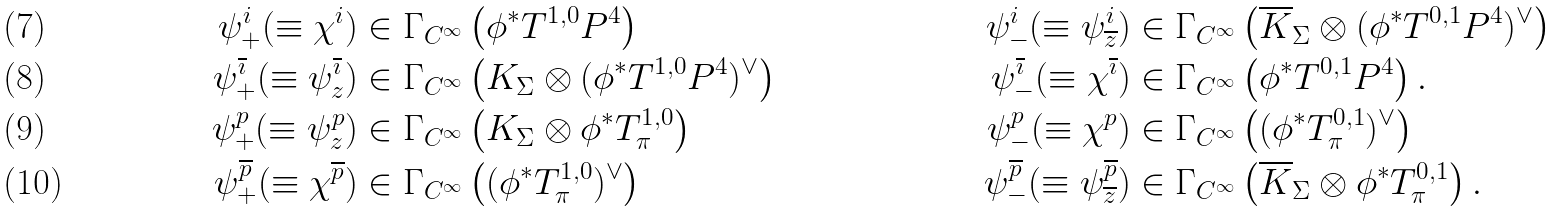<formula> <loc_0><loc_0><loc_500><loc_500>\psi _ { + } ^ { i } ( \equiv \chi ^ { i } ) & \in \Gamma _ { C ^ { \infty } } \left ( \phi ^ { * } T ^ { 1 , 0 } { P } ^ { 4 } \right ) & \psi _ { - } ^ { i } ( \equiv \psi _ { \overline { z } } ^ { i } ) & \in \Gamma _ { C ^ { \infty } } \left ( \overline { K } _ { \Sigma } \otimes ( \phi ^ { * } T ^ { 0 , 1 } { P } ^ { 4 } ) ^ { \vee } \right ) \\ \psi _ { + } ^ { \overline { \imath } } ( \equiv \psi _ { z } ^ { \overline { \imath } } ) & \in \Gamma _ { C ^ { \infty } } \left ( K _ { \Sigma } \otimes ( \phi ^ { * } T ^ { 1 , 0 } { P } ^ { 4 } ) ^ { \vee } \right ) & \psi _ { - } ^ { \overline { \imath } } ( \equiv \chi ^ { \overline { \imath } } ) & \in \Gamma _ { C ^ { \infty } } \left ( \phi ^ { * } T ^ { 0 , 1 } { P } ^ { 4 } \right ) . \\ \psi _ { + } ^ { p } ( \equiv \psi _ { z } ^ { p } ) & \in \Gamma _ { C ^ { \infty } } \left ( K _ { \Sigma } \otimes \phi ^ { * } T ^ { 1 , 0 } _ { \pi } \right ) & \psi _ { - } ^ { p } ( \equiv \chi ^ { p } ) & \in \Gamma _ { C ^ { \infty } } \left ( ( \phi ^ { * } T ^ { 0 , 1 } _ { \pi } ) ^ { \vee } \right ) \\ \psi _ { + } ^ { \overline { p } } ( \equiv \chi ^ { \overline { p } } ) & \in \Gamma _ { C ^ { \infty } } \left ( ( \phi ^ { * } T ^ { 1 , 0 } _ { \pi } ) ^ { \vee } \right ) & \psi _ { - } ^ { \overline { p } } ( \equiv \psi _ { \overline { z } } ^ { \overline { p } } ) & \in \Gamma _ { C ^ { \infty } } \left ( \overline { K } _ { \Sigma } \otimes \phi ^ { * } T ^ { 0 , 1 } _ { \pi } \right ) .</formula> 